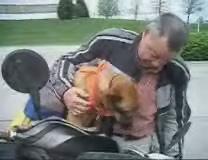How many animals are there?
Give a very brief answer. 1. How many motorcycles can you see?
Give a very brief answer. 1. 